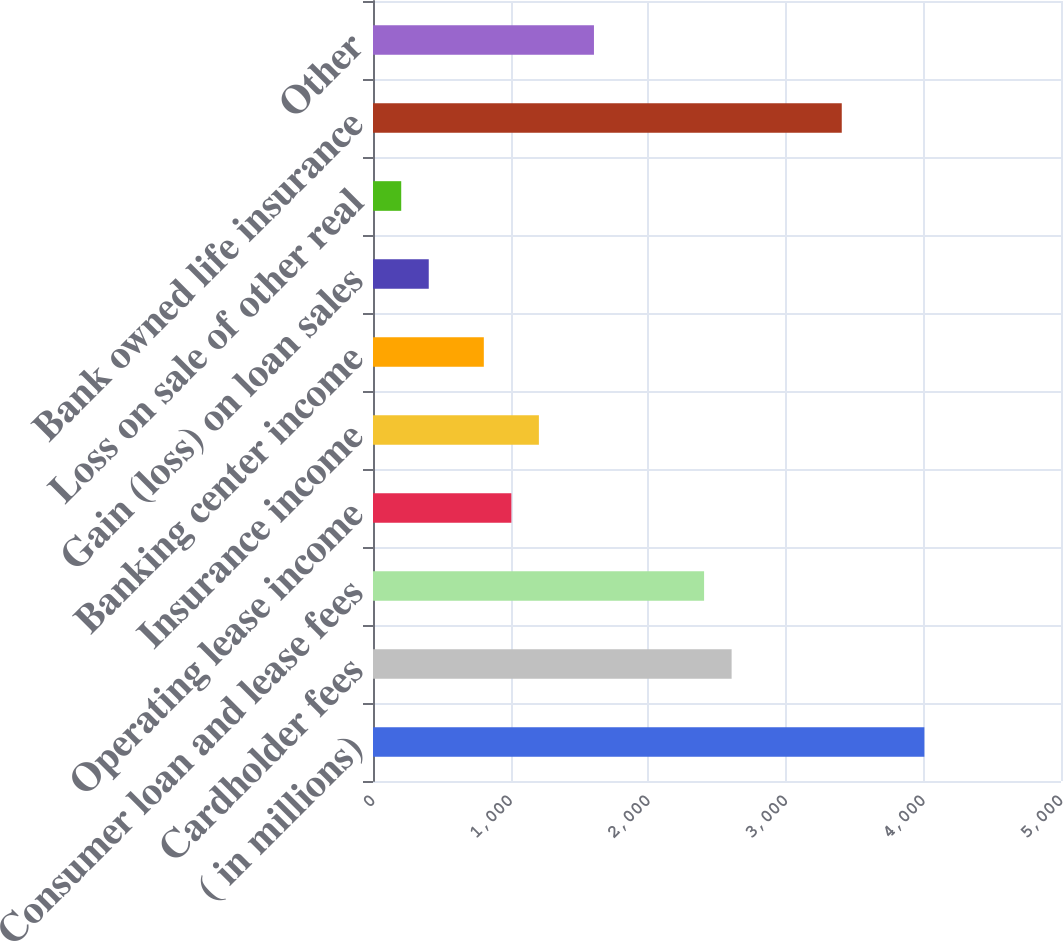<chart> <loc_0><loc_0><loc_500><loc_500><bar_chart><fcel>( in millions)<fcel>Cardholder fees<fcel>Consumer loan and lease fees<fcel>Operating lease income<fcel>Insurance income<fcel>Banking center income<fcel>Gain (loss) on loan sales<fcel>Loss on sale of other real<fcel>Bank owned life insurance<fcel>Other<nl><fcel>4007<fcel>2606.3<fcel>2406.2<fcel>1005.5<fcel>1205.6<fcel>805.4<fcel>405.2<fcel>205.1<fcel>3406.7<fcel>1605.8<nl></chart> 